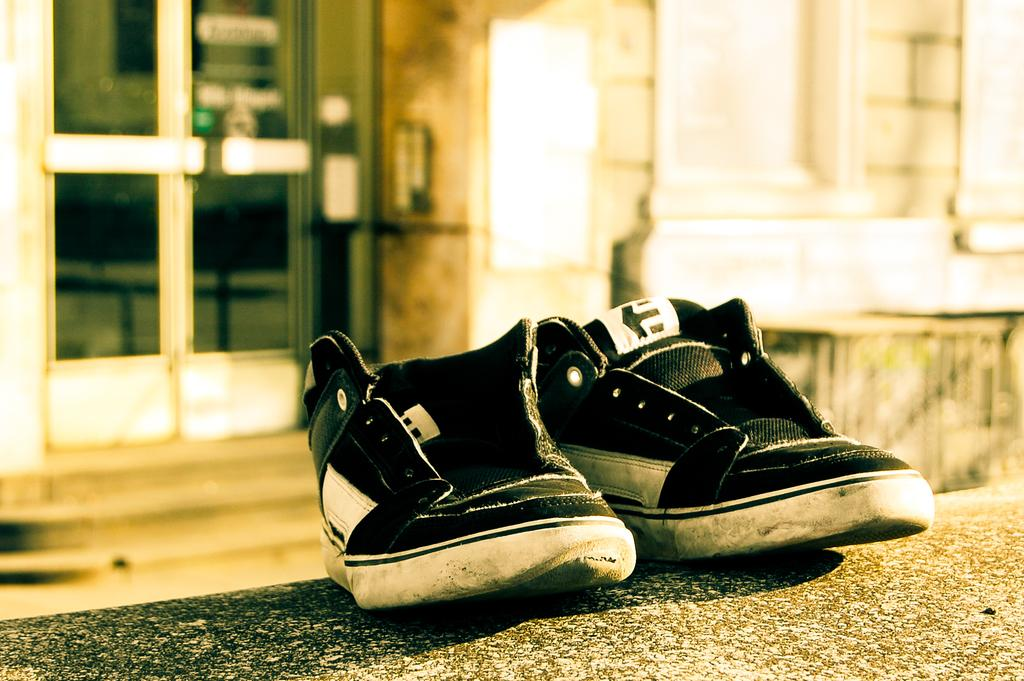What color are the shoes in the image? The shoes in the image are black. Where are the shoes located in the image? The shoes are in the middle of the image. What can be seen on the left side of the image? There are glass doors on the left side of the image. What is present in the background of the image? There is a wall in the image. Are there any plantations visible in the image? There are no plantations present in the image. Can you see a pig in the image? There is no pig visible in the image. 